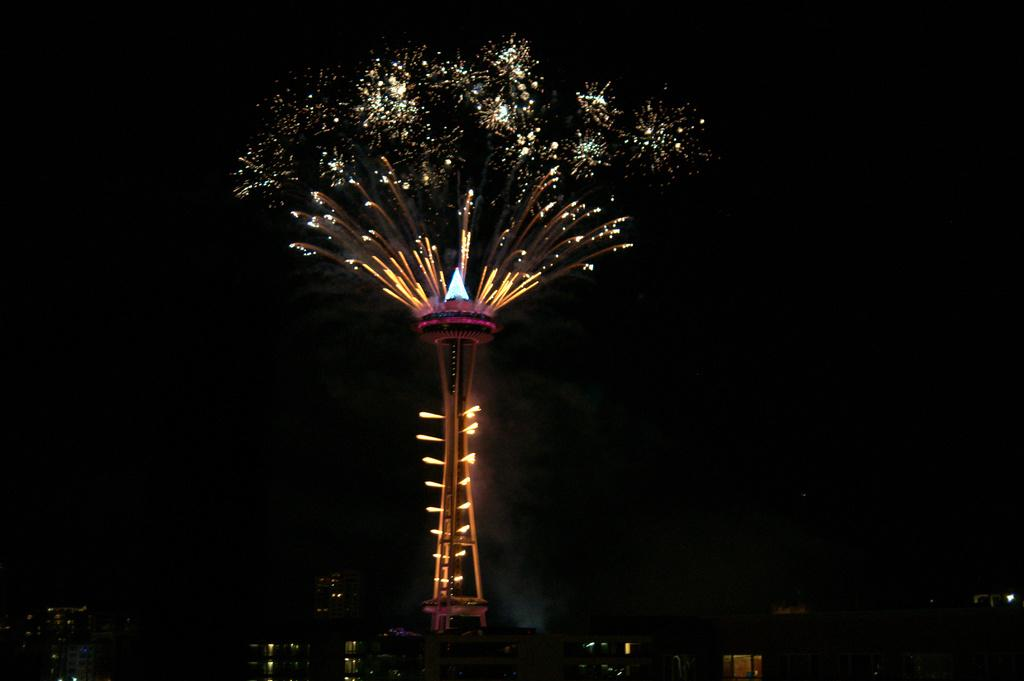What is the main structure in the picture? There is a tower in the picture. What feature does the tower have? The tower has lights. Where is the tower located in the image? The tower is in the middle of the image. What is visible at the top of the image? The sky is visible at the top of the image. Can you see any rain falling from the sky in the image? There is no rain visible in the image; only the tower and the sky are present. Is there a pocket on the tower in the image? There is no pocket on the tower in the image; it is a solid structure with lights. 